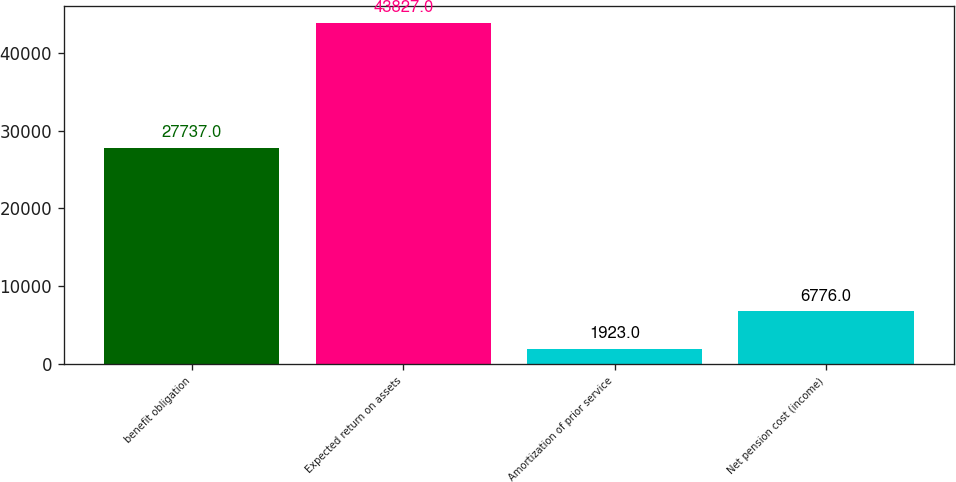Convert chart. <chart><loc_0><loc_0><loc_500><loc_500><bar_chart><fcel>benefit obligation<fcel>Expected return on assets<fcel>Amortization of prior service<fcel>Net pension cost (income)<nl><fcel>27737<fcel>43827<fcel>1923<fcel>6776<nl></chart> 